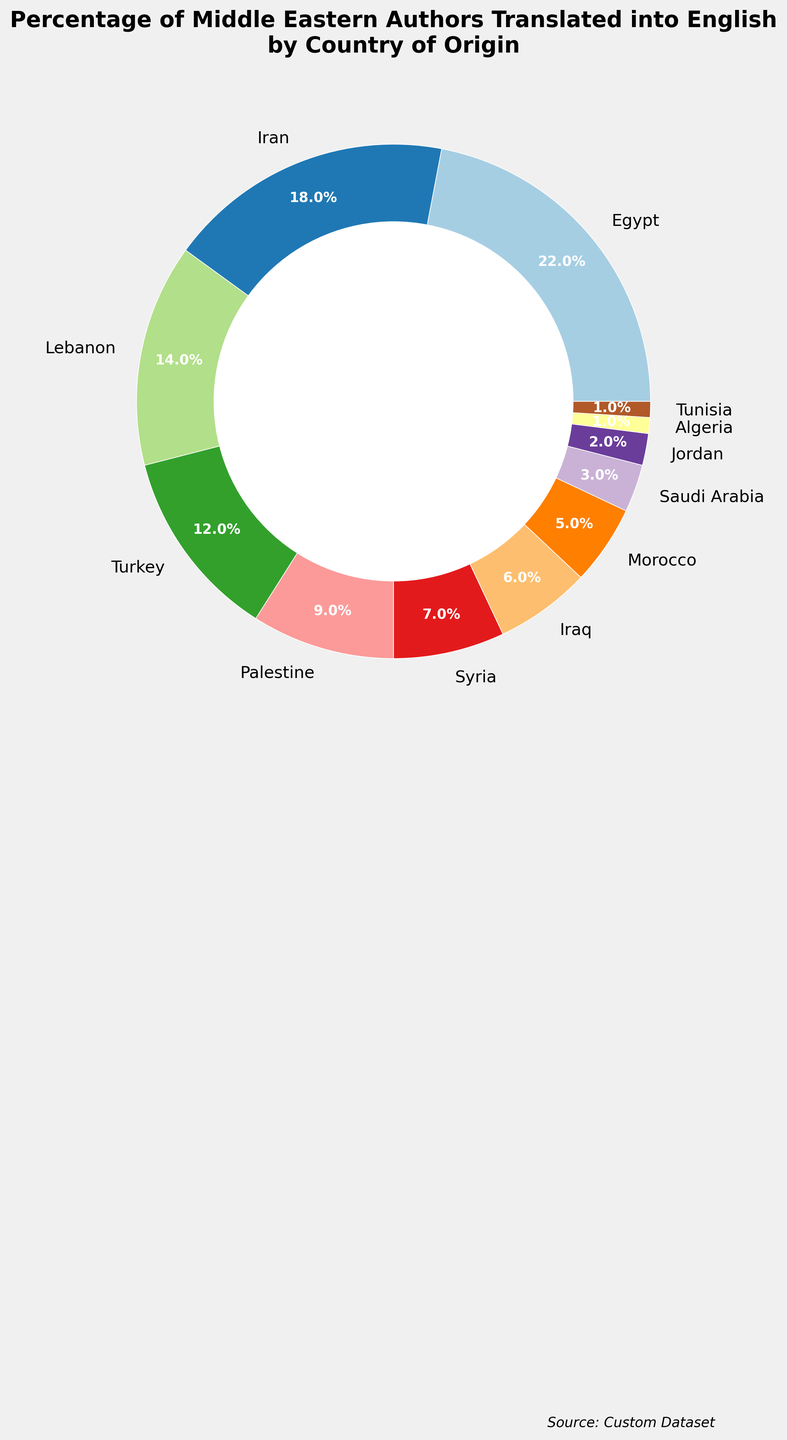What percentages do Egypt and Lebanon combined account for? Egypt is 22% and Lebanon is 14%. Adding these percentages, 22 + 14 = 36%.
Answer: 36% Which country has the smallest percentage of authors translated into English, and what is that percentage? Both Algeria and Tunisia have the smallest percentage of authors translated into English, which is 1% each.
Answer: Algeria and Tunisia, 1% How much more is the percentage for Egypt compared to the percentage for Iraq? Egypt's percentage is 22% and Iraq's percentage is 6%. The difference is 22 - 6 = 16%.
Answer: 16% Is the percentage for Syria greater than, less than, or equal to the percentage for Turkey? Syria's percentage is 7% and Turkey's percentage is 12%. 7 is less than 12.
Answer: Less than What is the combined percentage for the countries with less than 5%? The countries with less than 5% are Saudi Arabia (3%), Jordan (2%), Algeria (1%), and Tunisia (1%). Adding these gives 3 + 2 + 1 + 1 = 7%.
Answer: 7% What is the percentage difference between Iran and Palestine? Iran's percentage is 18% and Palestine's percentage is 9%. The difference is 18 - 9 = 9%.
Answer: 9% What percentage of Middle Eastern authors translated into English come from North African countries (Morocco, Algeria, and Tunisia)? Morocco is 5%, Algeria is 1%, and Tunisia is 1%. Adding these gives 5 + 1 + 1 = 7%.
Answer: 7% Which country has the second-highest percentage of authors translated into English, and what is that percentage? The second-highest percentage is for Iran, which has 18%.
Answer: Iran, 18% Is the percentage for Iraq closer to the percentage for Syria or to the percentage for Morocco? Iraq’s percentage is 6%. The difference with Syria (7%) is 1% and with Morocco (5%) it is 1%. They are equally close.
Answer: Equally close to both Within this dataset, how many countries have a percentage higher than 10%? The countries with more than 10% are Egypt, Iran, Lebanon, and Turkey. Total = 4.
Answer: 4 